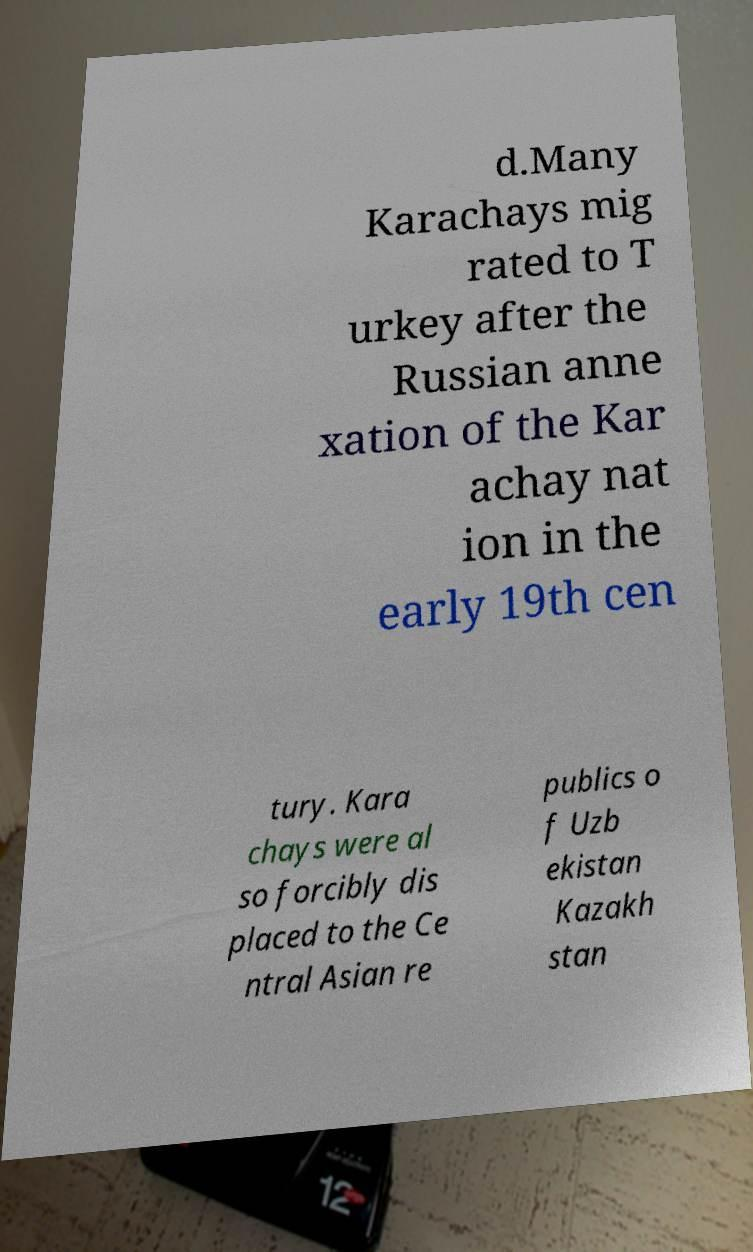There's text embedded in this image that I need extracted. Can you transcribe it verbatim? d.Many Karachays mig rated to T urkey after the Russian anne xation of the Kar achay nat ion in the early 19th cen tury. Kara chays were al so forcibly dis placed to the Ce ntral Asian re publics o f Uzb ekistan Kazakh stan 